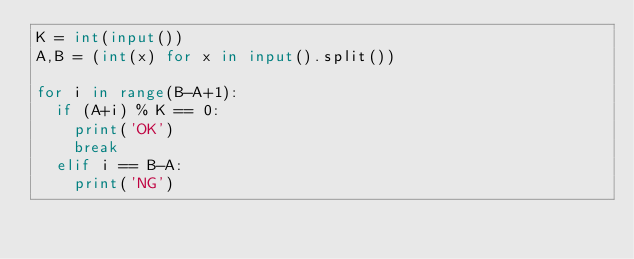<code> <loc_0><loc_0><loc_500><loc_500><_Python_>K = int(input())
A,B = (int(x) for x in input().split())

for i in range(B-A+1):
  if (A+i) % K == 0:
    print('OK')
    break
  elif i == B-A:
    print('NG')</code> 